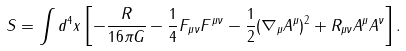<formula> <loc_0><loc_0><loc_500><loc_500>S = \int d ^ { 4 } x \left [ - \frac { R } { 1 6 \pi G } - \frac { 1 } { 4 } F _ { \mu \nu } F ^ { \mu \nu } - \frac { 1 } { 2 } ( \nabla _ { \mu } A ^ { \mu } ) ^ { 2 } + R _ { \mu \nu } A ^ { \mu } A ^ { \nu } \right ] .</formula> 